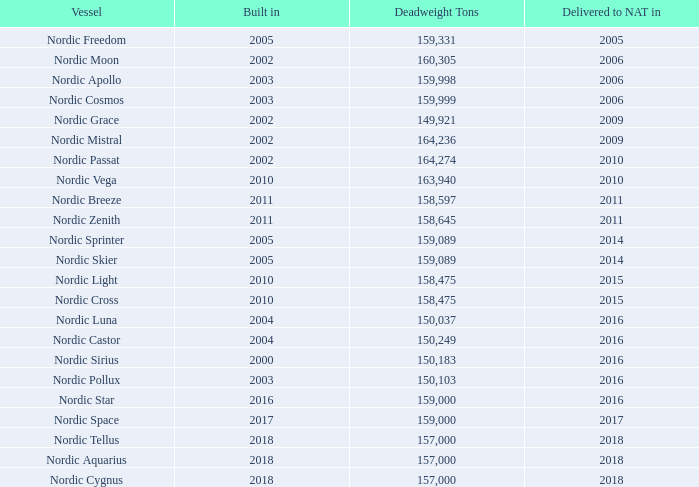1. NATURE OF BUSINESS
Nordic American Tankers Limited (“NAT”) was formed on June 12, 1995 under the laws of the Islands of Bermuda. The Company’s shares trade under the symbol “NAT” on the New York Stock Exchange. The Company was formed for the purpose of acquiring and chartering out double-hull tankers.
The Company is an international tanker company that currently has a fleet of 23 Suezmax tankers. The Company has not disposed of or acquired new vessels in 2019. The 23 vessels the Company operated per December 31, 2019, average approximately 156,000 dwt each. In 2019, 2018 and 2017, the Company chartered out its operating vessels primarily in the spot market.
The Company’s Fleet
The Company’s current fleet consists of 23 Suezmax crude oil tankers of which the vast majority have been built in Korea.
What are the respective years that Nordic Freedom is built and delivered to NAT? 2005, 2005. What are the respective years that Nordic Moon is built and delivered to NAT? 2002, 2006. What are the respective years that Nordic Apollo is built and delivered to NAT? 2003, 2006. What is the average weight of the Nordic Freedom and Nordic Moon? (159,331 + 160,305)/2 
Answer: 159818. What is the average weight of the Nordic Apollo and Nordic Cosmos? (159,998 + 159,999)/2 
Answer: 159998.5. What is the average weight of the Nordic Grace and Nordic Mistrals? (149,921 + 164,236)/2 
Answer: 157078.5. 